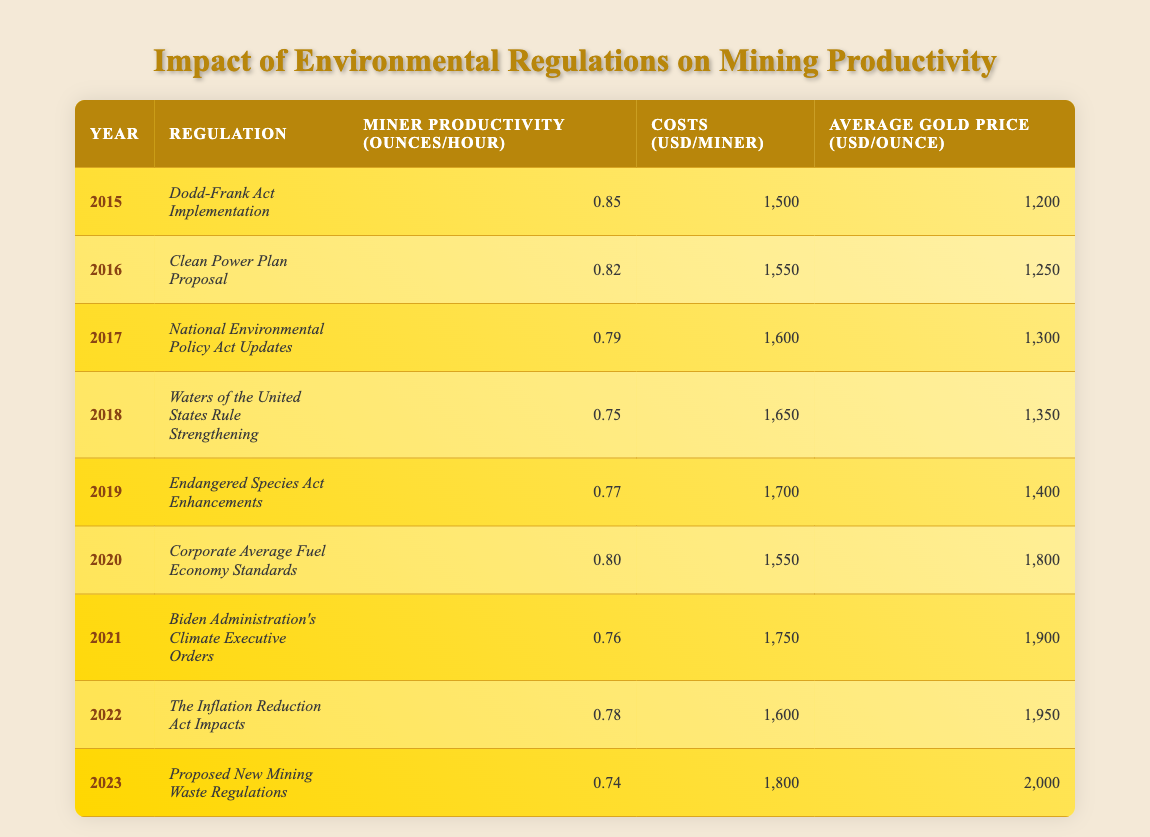What was the miner productivity in 2015? The table shows that in 2015, the miner productivity was recorded at 0.85 ounces per hour.
Answer: 0.85 What is the cost per miner in 2021? Looking at the table, the cost per miner in 2021 was reported as 1,750 USD.
Answer: 1,750 Did the average gold price increase from 2019 to 2022? By checking the average gold prices, in 2019 it was 1,400 USD and in 2022 it was 1,950 USD. Since 1,950 is greater than 1,400, the price did increase.
Answer: Yes What is the difference in miner productivity between 2015 and 2023? In 2015, the miner productivity was 0.85 ounces/hour, and in 2023 it was 0.74 ounces/hour. The difference is calculated as 0.85 - 0.74 = 0.11 ounces/hour.
Answer: 0.11 What is the average cost per miner from 2015 to 2023? First, sum up the costs: 1500 + 1550 + 1600 + 1650 + 1700 + 1550 + 1750 + 1600 + 1800 = 14,100 USD. Then, divide this total by the number of years, which is 9: 14,100 / 9 = 1,566.67 USD. So, the average cost per miner is approximately 1,567 USD.
Answer: 1,567 What regulation was implemented in 2017? The table indicates that in 2017, the regulation implemented was the National Environmental Policy Act Updates.
Answer: National Environmental Policy Act Updates Was there a decrease in miner productivity from 2016 to 2018? In 2016 miner productivity was 0.82 ounces/hour, and in 2018 it dropped to 0.75 ounces/hour. Since 0.75 is less than 0.82, it confirms a decrease in miner productivity.
Answer: Yes What was the trend in costs from 2015 to 2023? Observing the costs over the years: 1500, 1550, 1600, 1650, 1700, 1550, 1750, 1600, and 1800 indicates an overall increase, despite slight fluctuations in some years. The final cost in 2023 shows an increase compared to 2015.
Answer: Overall increase 